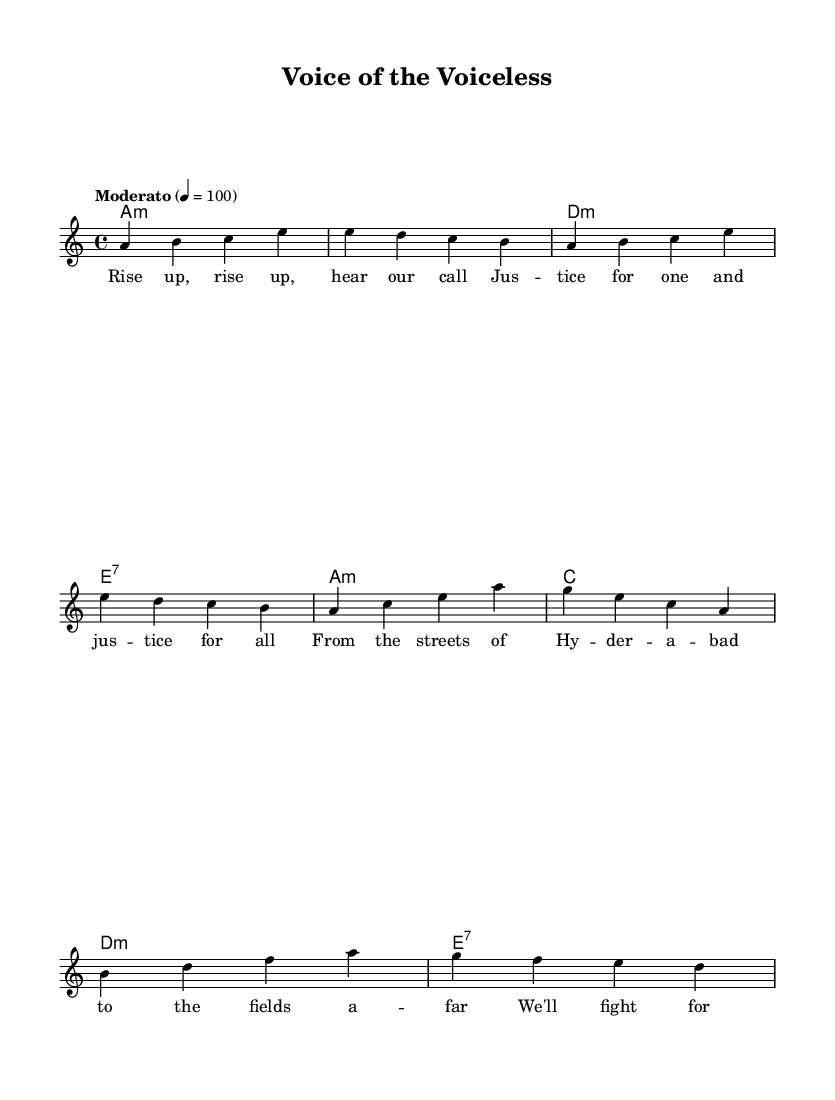What is the key signature of this music? The key signature is A minor, which is indicated by the absence of sharp or flat symbols on the staff, and is confirmed by the first note, A, which establishes the tonal center.
Answer: A minor What is the time signature of this piece? The time signature is 4/4, which is represented by the notation at the beginning of the piece. This indicates that there are four beats in a measure and a quarter note receives one beat.
Answer: 4/4 What is the tempo marking for this music? The tempo marking is "Moderato," which is a common term in music indicating a moderate speed, typically between 76 and 108 beats per minute. The note "4 = 100" specifies the beats per minute.
Answer: Moderato How many measures are there in the melody? There are 8 measures in the melody, which can be counted by identifying the vertical bar lines that separate the groups of notes on the staff.
Answer: 8 measures What is the lyrical theme of the song? The lyrical theme is about justice and social activism, as conveyed through phrases like "Justice for one and justice for all" and "We'll fight for what's right." This reflects the essence of folk music addressing social issues.
Answer: Justice and social activism What type of chord progression is primarily used in this piece? The chord progression primarily follows a minor-key structure with typical folk features, using minor and dominant seventh chords, creating a somber yet hopeful atmosphere. The specific chords A minor, D minor, and E7 are highlighted throughout.
Answer: Minor-key progression What do the lyrics indicate about the intended message of this folk song? The lyrics indicate a message of unity and resistance against social injustice, urging people to rise up collectively. This aligns with the folk tradition of using music as a tool for social change and advocacy for rights.
Answer: Unity and resistance 